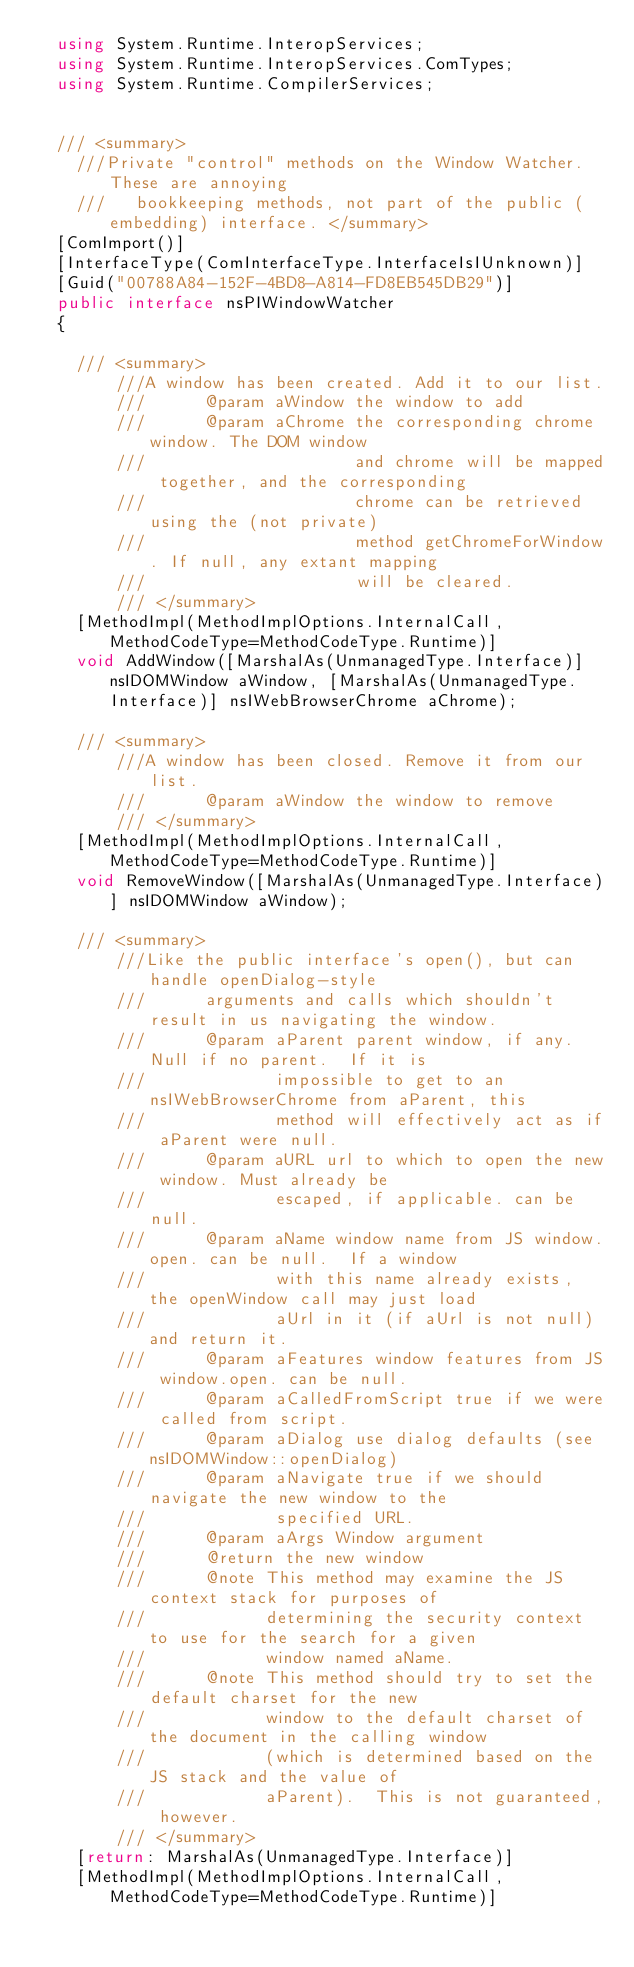Convert code to text. <code><loc_0><loc_0><loc_500><loc_500><_C#_>	using System.Runtime.InteropServices;
	using System.Runtime.InteropServices.ComTypes;
	using System.Runtime.CompilerServices;
	
	
	/// <summary>
    ///Private "control" methods on the Window Watcher. These are annoying
    ///   bookkeeping methods, not part of the public (embedding) interface. </summary>
	[ComImport()]
	[InterfaceType(ComInterfaceType.InterfaceIsIUnknown)]
	[Guid("00788A84-152F-4BD8-A814-FD8EB545DB29")]
	public interface nsPIWindowWatcher
	{
		
		/// <summary>
        ///A window has been created. Add it to our list.
        ///      @param aWindow the window to add
        ///      @param aChrome the corresponding chrome window. The DOM window
        ///                     and chrome will be mapped together, and the corresponding
        ///                     chrome can be retrieved using the (not private)
        ///                     method getChromeForWindow. If null, any extant mapping
        ///                     will be cleared.
        /// </summary>
		[MethodImpl(MethodImplOptions.InternalCall, MethodCodeType=MethodCodeType.Runtime)]
		void AddWindow([MarshalAs(UnmanagedType.Interface)] nsIDOMWindow aWindow, [MarshalAs(UnmanagedType.Interface)] nsIWebBrowserChrome aChrome);
		
		/// <summary>
        ///A window has been closed. Remove it from our list.
        ///      @param aWindow the window to remove
        /// </summary>
		[MethodImpl(MethodImplOptions.InternalCall, MethodCodeType=MethodCodeType.Runtime)]
		void RemoveWindow([MarshalAs(UnmanagedType.Interface)] nsIDOMWindow aWindow);
		
		/// <summary>
        ///Like the public interface's open(), but can handle openDialog-style
        ///      arguments and calls which shouldn't result in us navigating the window.
        ///      @param aParent parent window, if any. Null if no parent.  If it is
        ///             impossible to get to an nsIWebBrowserChrome from aParent, this
        ///             method will effectively act as if aParent were null.
        ///      @param aURL url to which to open the new window. Must already be
        ///             escaped, if applicable. can be null.
        ///      @param aName window name from JS window.open. can be null.  If a window
        ///             with this name already exists, the openWindow call may just load
        ///             aUrl in it (if aUrl is not null) and return it.
        ///      @param aFeatures window features from JS window.open. can be null.
        ///      @param aCalledFromScript true if we were called from script.
        ///      @param aDialog use dialog defaults (see nsIDOMWindow::openDialog)
        ///      @param aNavigate true if we should navigate the new window to the
        ///             specified URL.
        ///      @param aArgs Window argument
        ///      @return the new window
        ///      @note This method may examine the JS context stack for purposes of
        ///            determining the security context to use for the search for a given
        ///            window named aName.
        ///      @note This method should try to set the default charset for the new
        ///            window to the default charset of the document in the calling window
        ///            (which is determined based on the JS stack and the value of
        ///            aParent).  This is not guaranteed, however.
        /// </summary>
		[return: MarshalAs(UnmanagedType.Interface)]
		[MethodImpl(MethodImplOptions.InternalCall, MethodCodeType=MethodCodeType.Runtime)]</code> 